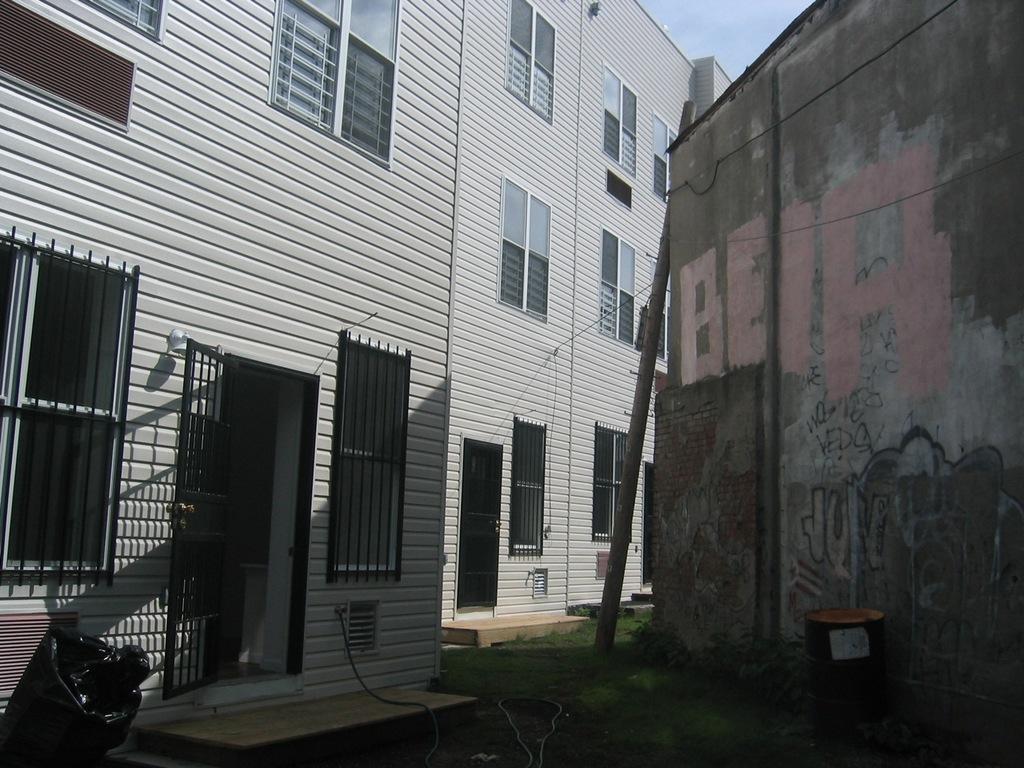Could you give a brief overview of what you see in this image? In this image we can see door, windows, buildings and sky. 